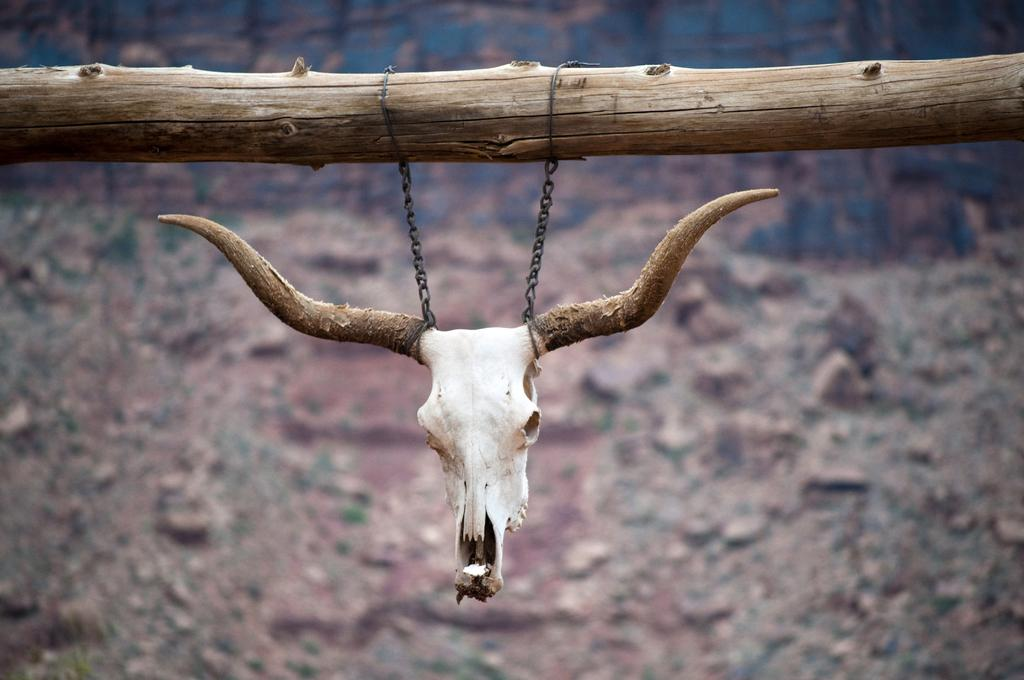What is the main subject of the image? The main subject of the image is a skull of an animal. How is the skull positioned in the image? The skull is hanged on a wooden log. What can be seen at the bottom of the image? There are stones at the bottom of the image. What type of weather can be seen in the image? The image does not depict any weather conditions, as it focuses on the skull and its surroundings. How many feet are visible in the image? There are no feet visible in the image; it only features the skull, wooden log, and stones. 